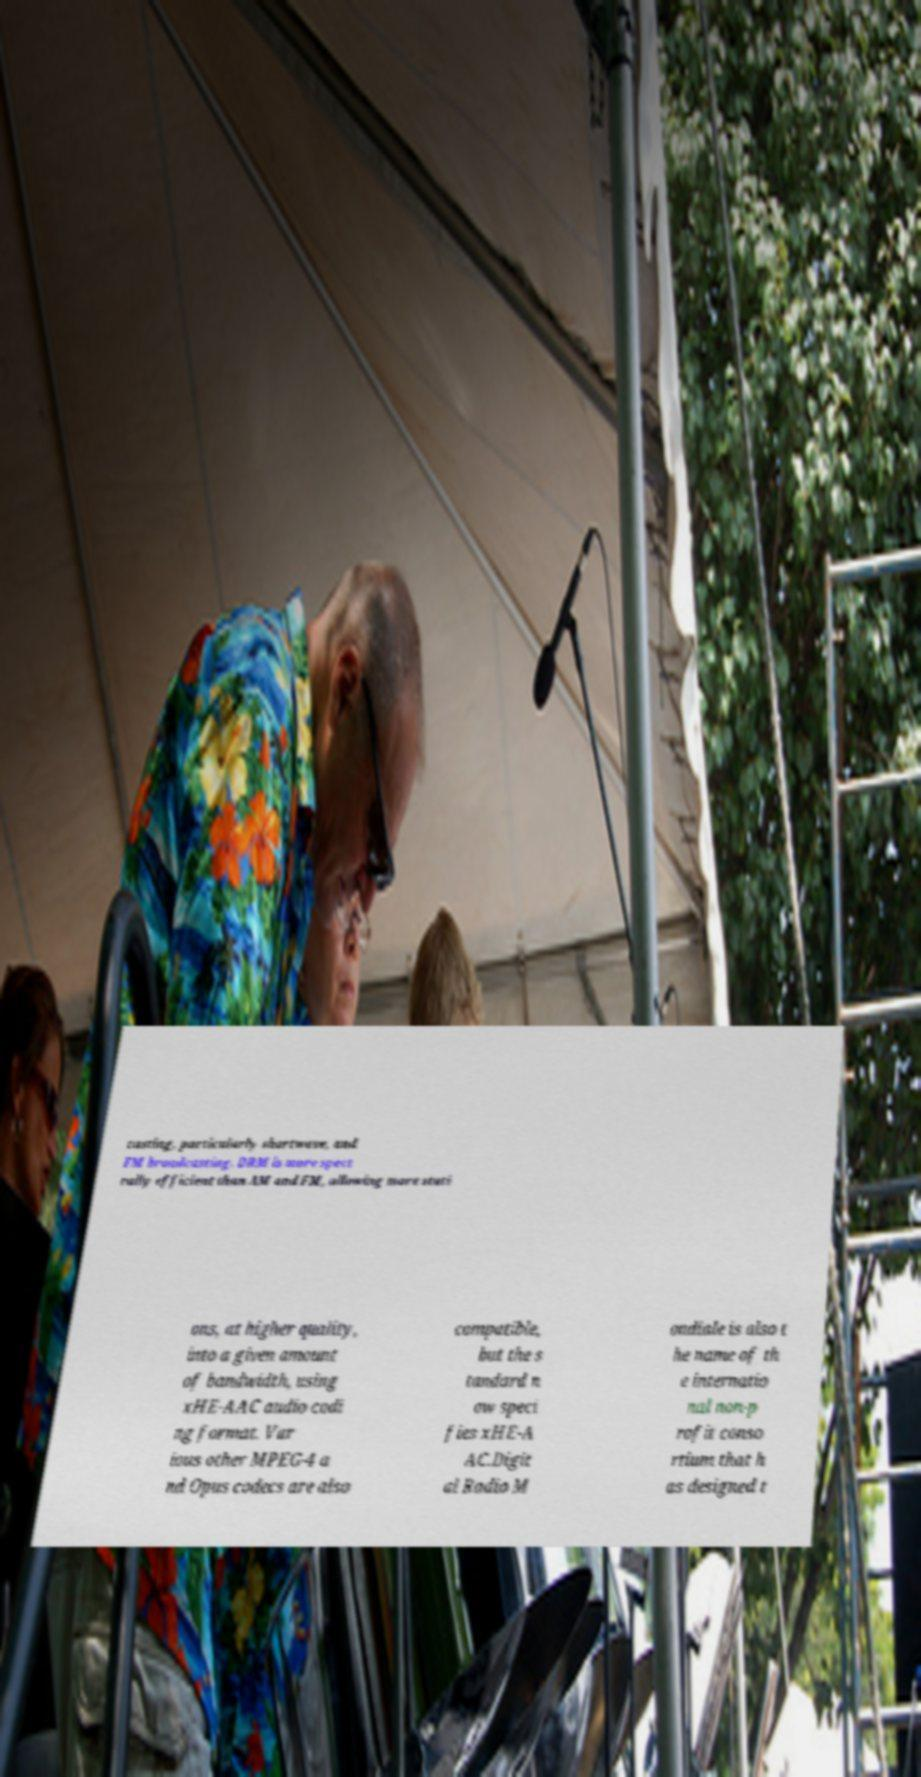There's text embedded in this image that I need extracted. Can you transcribe it verbatim? casting, particularly shortwave, and FM broadcasting. DRM is more spect rally efficient than AM and FM, allowing more stati ons, at higher quality, into a given amount of bandwidth, using xHE-AAC audio codi ng format. Var ious other MPEG-4 a nd Opus codecs are also compatible, but the s tandard n ow speci fies xHE-A AC.Digit al Radio M ondiale is also t he name of th e internatio nal non-p rofit conso rtium that h as designed t 